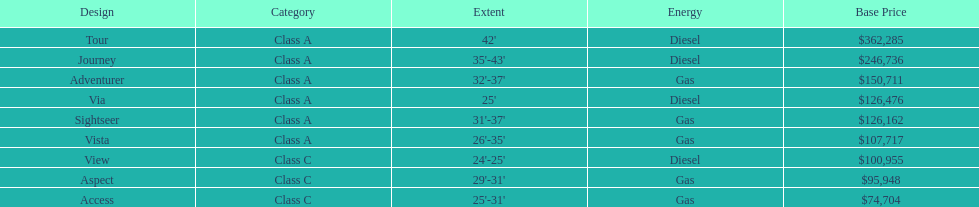Which model has the lowest started price? Access. 